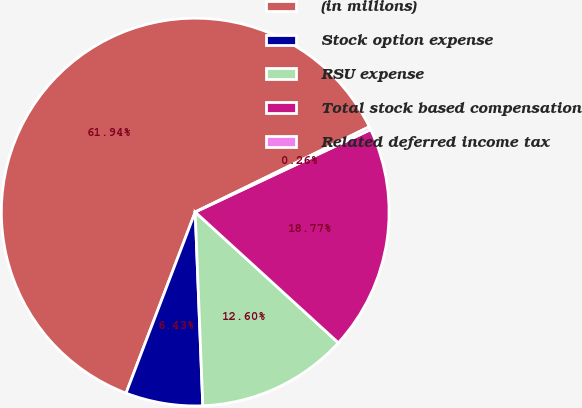Convert chart to OTSL. <chart><loc_0><loc_0><loc_500><loc_500><pie_chart><fcel>(in millions)<fcel>Stock option expense<fcel>RSU expense<fcel>Total stock based compensation<fcel>Related deferred income tax<nl><fcel>61.95%<fcel>6.43%<fcel>12.6%<fcel>18.77%<fcel>0.26%<nl></chart> 